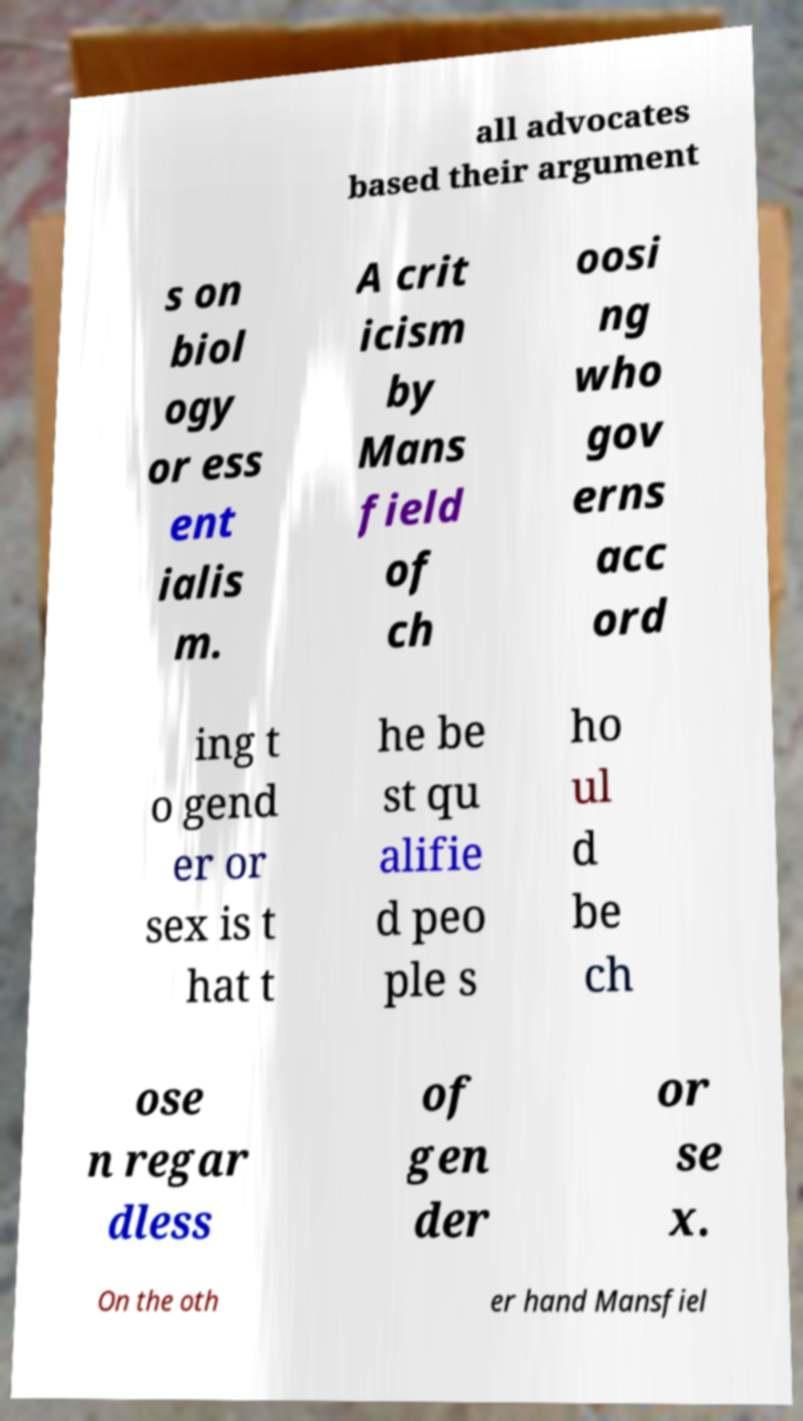Could you assist in decoding the text presented in this image and type it out clearly? all advocates based their argument s on biol ogy or ess ent ialis m. A crit icism by Mans field of ch oosi ng who gov erns acc ord ing t o gend er or sex is t hat t he be st qu alifie d peo ple s ho ul d be ch ose n regar dless of gen der or se x. On the oth er hand Mansfiel 